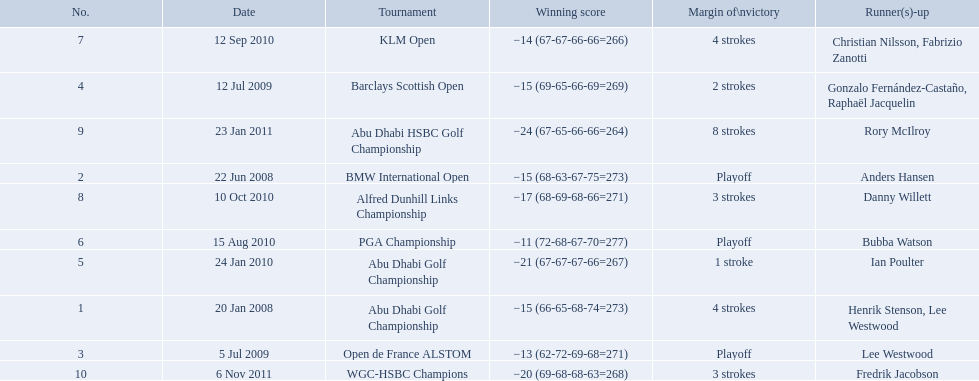What were all of the tournaments martin played in? Abu Dhabi Golf Championship, BMW International Open, Open de France ALSTOM, Barclays Scottish Open, Abu Dhabi Golf Championship, PGA Championship, KLM Open, Alfred Dunhill Links Championship, Abu Dhabi HSBC Golf Championship, WGC-HSBC Champions. And how many strokes did he score? −15 (66-65-68-74=273), −15 (68-63-67-75=273), −13 (62-72-69-68=271), −15 (69-65-66-69=269), −21 (67-67-67-66=267), −11 (72-68-67-70=277), −14 (67-67-66-66=266), −17 (68-69-68-66=271), −24 (67-65-66-66=264), −20 (69-68-68-63=268). What about during barclays and klm? −15 (69-65-66-69=269), −14 (67-67-66-66=266). How many more were scored in klm? 2 strokes. 